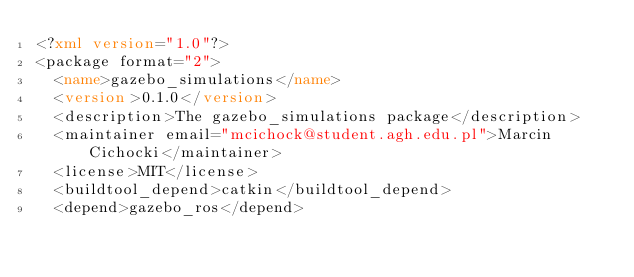Convert code to text. <code><loc_0><loc_0><loc_500><loc_500><_XML_><?xml version="1.0"?>
<package format="2">
  <name>gazebo_simulations</name>
  <version>0.1.0</version>
  <description>The gazebo_simulations package</description>
  <maintainer email="mcichock@student.agh.edu.pl">Marcin Cichocki</maintainer>
  <license>MIT</license>
  <buildtool_depend>catkin</buildtool_depend>
  <depend>gazebo_ros</depend></code> 